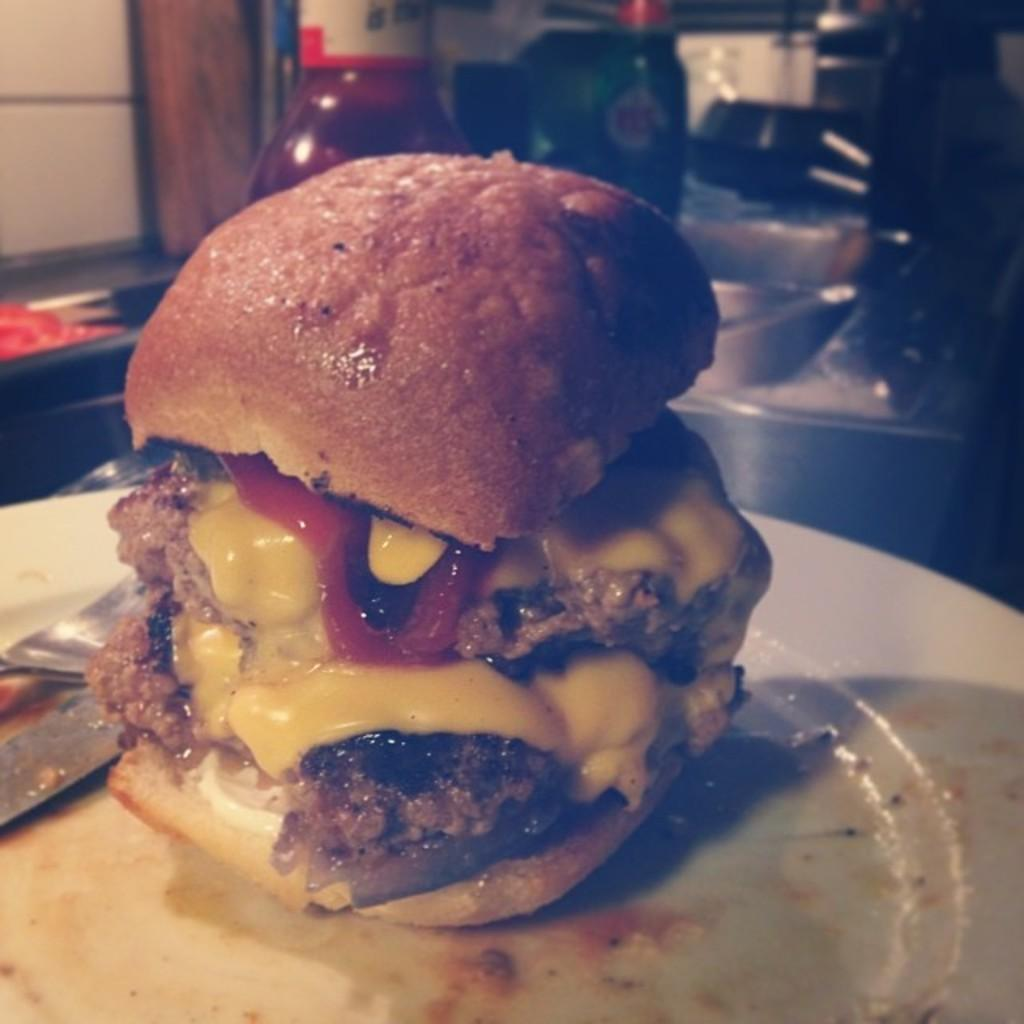What type of food is shown in the image? There is a burger in the image. How is the burger presented? The burger is served on a plate. What else can be seen in the image related to food preparation or serving? There are cooking utensils visible behind the burger. What type of peace treaty is being discussed in the image? There is no reference to a peace treaty or any discussion in the image; it features a burger served on a plate with cooking utensils visible behind it. 